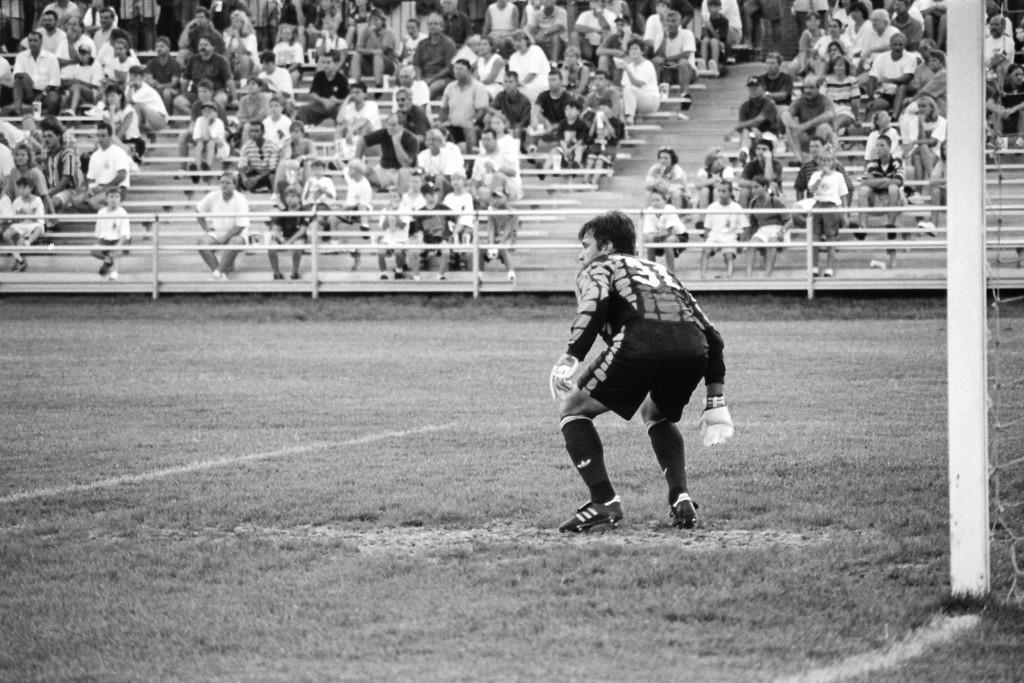Can you describe this image briefly? In this picture we can see a person standing on the ground, he is wearing gloves and in the background we can see a fence and a group of people. 